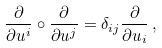Convert formula to latex. <formula><loc_0><loc_0><loc_500><loc_500>\frac { \partial } { \partial u ^ { i } } \circ \frac { \partial } { \partial u ^ { j } } = \delta _ { i j } \frac { \partial } { \partial u _ { i } } \, ,</formula> 